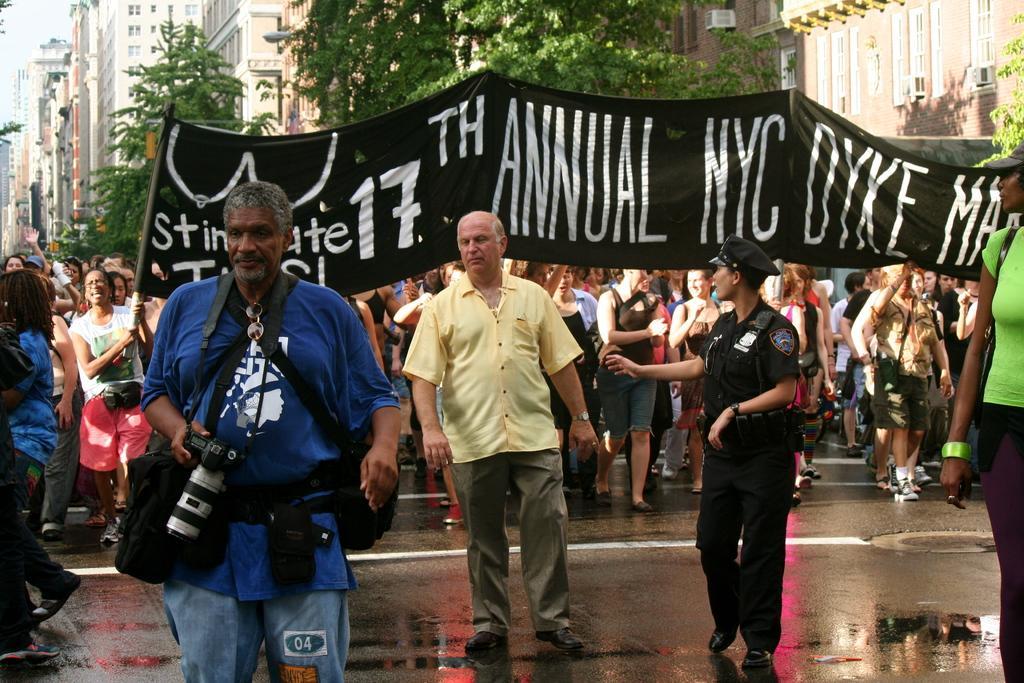Please provide a concise description of this image. In this image we can see a group of people on the ground. In that a man is holding a camera. On the backside we can see some people holding a banner containing some text on it. We can also see some buildings with windows, trees and the sky. 